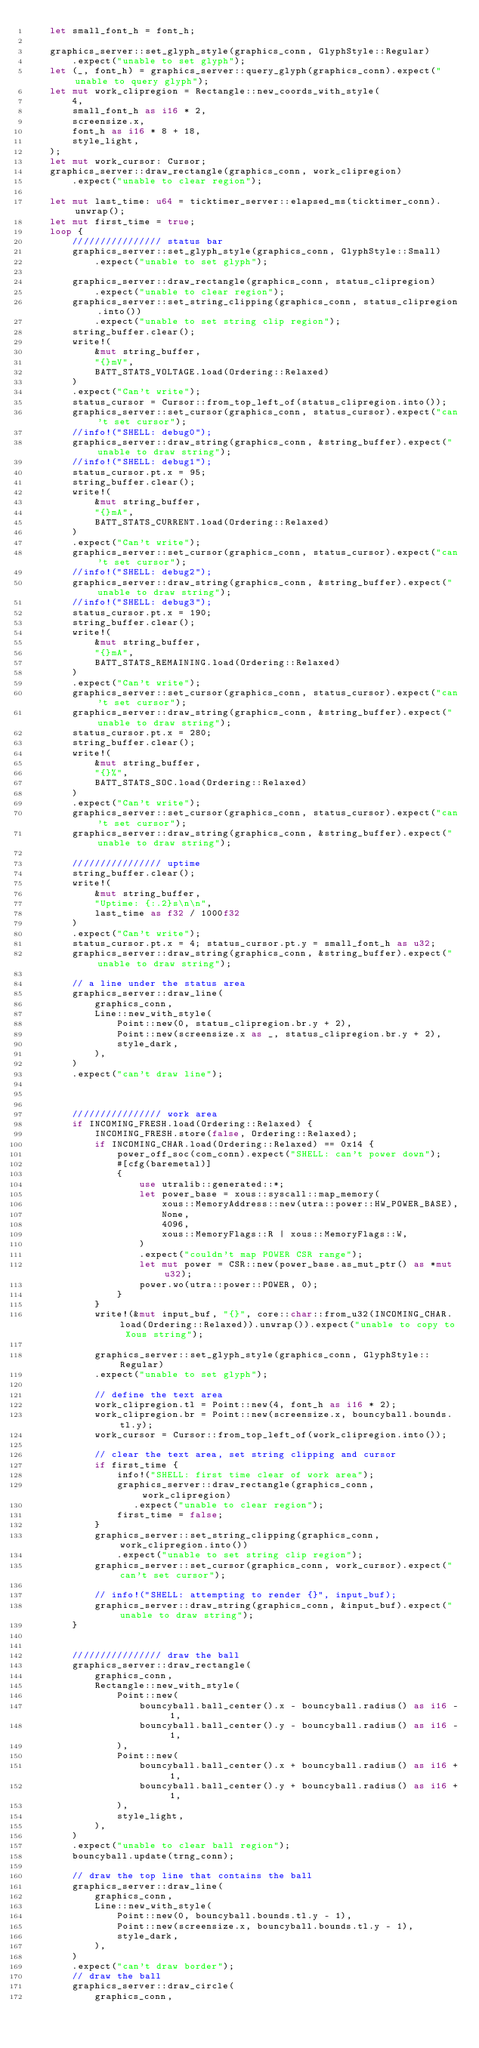<code> <loc_0><loc_0><loc_500><loc_500><_Rust_>    let small_font_h = font_h;

    graphics_server::set_glyph_style(graphics_conn, GlyphStyle::Regular)
        .expect("unable to set glyph");
    let (_, font_h) = graphics_server::query_glyph(graphics_conn).expect("unable to query glyph");
    let mut work_clipregion = Rectangle::new_coords_with_style(
        4,
        small_font_h as i16 * 2,
        screensize.x,
        font_h as i16 * 8 + 18,
        style_light,
    );
    let mut work_cursor: Cursor;
    graphics_server::draw_rectangle(graphics_conn, work_clipregion)
        .expect("unable to clear region");

    let mut last_time: u64 = ticktimer_server::elapsed_ms(ticktimer_conn).unwrap();
    let mut first_time = true;
    loop {
        //////////////// status bar
        graphics_server::set_glyph_style(graphics_conn, GlyphStyle::Small)
            .expect("unable to set glyph");

        graphics_server::draw_rectangle(graphics_conn, status_clipregion)
            .expect("unable to clear region");
        graphics_server::set_string_clipping(graphics_conn, status_clipregion.into())
            .expect("unable to set string clip region");
        string_buffer.clear();
        write!(
            &mut string_buffer,
            "{}mV",
            BATT_STATS_VOLTAGE.load(Ordering::Relaxed)
        )
        .expect("Can't write");
        status_cursor = Cursor::from_top_left_of(status_clipregion.into());
        graphics_server::set_cursor(graphics_conn, status_cursor).expect("can't set cursor");
        //info!("SHELL: debug0");
        graphics_server::draw_string(graphics_conn, &string_buffer).expect("unable to draw string");
        //info!("SHELL: debug1");
        status_cursor.pt.x = 95;
        string_buffer.clear();
        write!(
            &mut string_buffer,
            "{}mA",
            BATT_STATS_CURRENT.load(Ordering::Relaxed)
        )
        .expect("Can't write");
        graphics_server::set_cursor(graphics_conn, status_cursor).expect("can't set cursor");
        //info!("SHELL: debug2");
        graphics_server::draw_string(graphics_conn, &string_buffer).expect("unable to draw string");
        //info!("SHELL: debug3");
        status_cursor.pt.x = 190;
        string_buffer.clear();
        write!(
            &mut string_buffer,
            "{}mA",
            BATT_STATS_REMAINING.load(Ordering::Relaxed)
        )
        .expect("Can't write");
        graphics_server::set_cursor(graphics_conn, status_cursor).expect("can't set cursor");
        graphics_server::draw_string(graphics_conn, &string_buffer).expect("unable to draw string");
        status_cursor.pt.x = 280;
        string_buffer.clear();
        write!(
            &mut string_buffer,
            "{}%",
            BATT_STATS_SOC.load(Ordering::Relaxed)
        )
        .expect("Can't write");
        graphics_server::set_cursor(graphics_conn, status_cursor).expect("can't set cursor");
        graphics_server::draw_string(graphics_conn, &string_buffer).expect("unable to draw string");

        //////////////// uptime
        string_buffer.clear();
        write!(
            &mut string_buffer,
            "Uptime: {:.2}s\n\n",
            last_time as f32 / 1000f32
        )
        .expect("Can't write");
        status_cursor.pt.x = 4; status_cursor.pt.y = small_font_h as u32;
        graphics_server::draw_string(graphics_conn, &string_buffer).expect("unable to draw string");

        // a line under the status area
        graphics_server::draw_line(
            graphics_conn,
            Line::new_with_style(
                Point::new(0, status_clipregion.br.y + 2),
                Point::new(screensize.x as _, status_clipregion.br.y + 2),
                style_dark,
            ),
        )
        .expect("can't draw line");



        //////////////// work area
        if INCOMING_FRESH.load(Ordering::Relaxed) {
            INCOMING_FRESH.store(false, Ordering::Relaxed);
            if INCOMING_CHAR.load(Ordering::Relaxed) == 0x14 {
                power_off_soc(com_conn).expect("SHELL: can't power down");
                #[cfg(baremetal)]
                {
                    use utralib::generated::*;
                    let power_base = xous::syscall::map_memory(
                        xous::MemoryAddress::new(utra::power::HW_POWER_BASE),
                        None,
                        4096,
                        xous::MemoryFlags::R | xous::MemoryFlags::W,
                    )
                    .expect("couldn't map POWER CSR range");
                    let mut power = CSR::new(power_base.as_mut_ptr() as *mut u32);
                    power.wo(utra::power::POWER, 0);
                }
            }
            write!(&mut input_buf, "{}", core::char::from_u32(INCOMING_CHAR.load(Ordering::Relaxed)).unwrap()).expect("unable to copy to Xous string");

            graphics_server::set_glyph_style(graphics_conn, GlyphStyle::Regular)
            .expect("unable to set glyph");

            // define the text area
            work_clipregion.tl = Point::new(4, font_h as i16 * 2);
            work_clipregion.br = Point::new(screensize.x, bouncyball.bounds.tl.y);
            work_cursor = Cursor::from_top_left_of(work_clipregion.into());

            // clear the text area, set string clipping and cursor
            if first_time {
                info!("SHELL: first time clear of work area");
                graphics_server::draw_rectangle(graphics_conn, work_clipregion)
                   .expect("unable to clear region");
                first_time = false;
            }
            graphics_server::set_string_clipping(graphics_conn, work_clipregion.into())
                .expect("unable to set string clip region");
            graphics_server::set_cursor(graphics_conn, work_cursor).expect("can't set cursor");

            // info!("SHELL: attempting to render {}", input_buf);
            graphics_server::draw_string(graphics_conn, &input_buf).expect("unable to draw string");
        }


        //////////////// draw the ball
        graphics_server::draw_rectangle(
            graphics_conn,
            Rectangle::new_with_style(
                Point::new(
                    bouncyball.ball_center().x - bouncyball.radius() as i16 - 1,
                    bouncyball.ball_center().y - bouncyball.radius() as i16 - 1,
                ),
                Point::new(
                    bouncyball.ball_center().x + bouncyball.radius() as i16 + 1,
                    bouncyball.ball_center().y + bouncyball.radius() as i16 + 1,
                ),
                style_light,
            ),
        )
        .expect("unable to clear ball region");
        bouncyball.update(trng_conn);

        // draw the top line that contains the ball
        graphics_server::draw_line(
            graphics_conn,
            Line::new_with_style(
                Point::new(0, bouncyball.bounds.tl.y - 1),
                Point::new(screensize.x, bouncyball.bounds.tl.y - 1),
                style_dark,
            ),
        )
        .expect("can't draw border");
        // draw the ball
        graphics_server::draw_circle(
            graphics_conn,</code> 